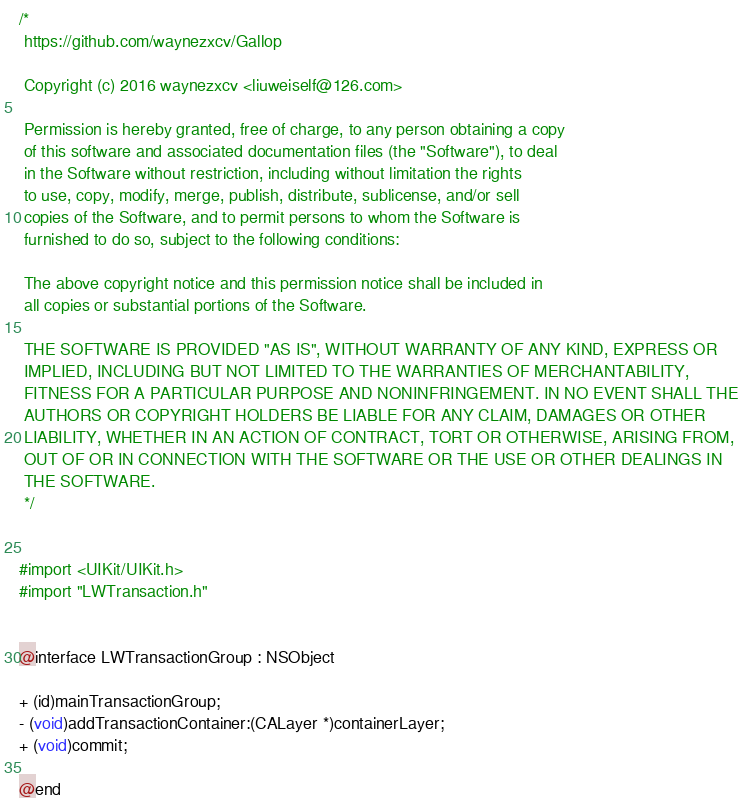Convert code to text. <code><loc_0><loc_0><loc_500><loc_500><_C_>/*
 https://github.com/waynezxcv/Gallop

 Copyright (c) 2016 waynezxcv <liuweiself@126.com>

 Permission is hereby granted, free of charge, to any person obtaining a copy
 of this software and associated documentation files (the "Software"), to deal
 in the Software without restriction, including without limitation the rights
 to use, copy, modify, merge, publish, distribute, sublicense, and/or sell
 copies of the Software, and to permit persons to whom the Software is
 furnished to do so, subject to the following conditions:

 The above copyright notice and this permission notice shall be included in
 all copies or substantial portions of the Software.

 THE SOFTWARE IS PROVIDED "AS IS", WITHOUT WARRANTY OF ANY KIND, EXPRESS OR
 IMPLIED, INCLUDING BUT NOT LIMITED TO THE WARRANTIES OF MERCHANTABILITY,
 FITNESS FOR A PARTICULAR PURPOSE AND NONINFRINGEMENT. IN NO EVENT SHALL THE
 AUTHORS OR COPYRIGHT HOLDERS BE LIABLE FOR ANY CLAIM, DAMAGES OR OTHER
 LIABILITY, WHETHER IN AN ACTION OF CONTRACT, TORT OR OTHERWISE, ARISING FROM,
 OUT OF OR IN CONNECTION WITH THE SOFTWARE OR THE USE OR OTHER DEALINGS IN
 THE SOFTWARE.
 */


#import <UIKit/UIKit.h>
#import "LWTransaction.h"


@interface LWTransactionGroup : NSObject

+ (id)mainTransactionGroup;
- (void)addTransactionContainer:(CALayer *)containerLayer;
+ (void)commit;

@end
</code> 